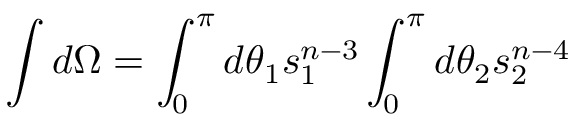<formula> <loc_0><loc_0><loc_500><loc_500>\int d \Omega = \int _ { 0 } ^ { \pi } d \theta _ { 1 } s _ { 1 } ^ { n - 3 } \int _ { 0 } ^ { \pi } d \theta _ { 2 } s _ { 2 } ^ { n - 4 }</formula> 